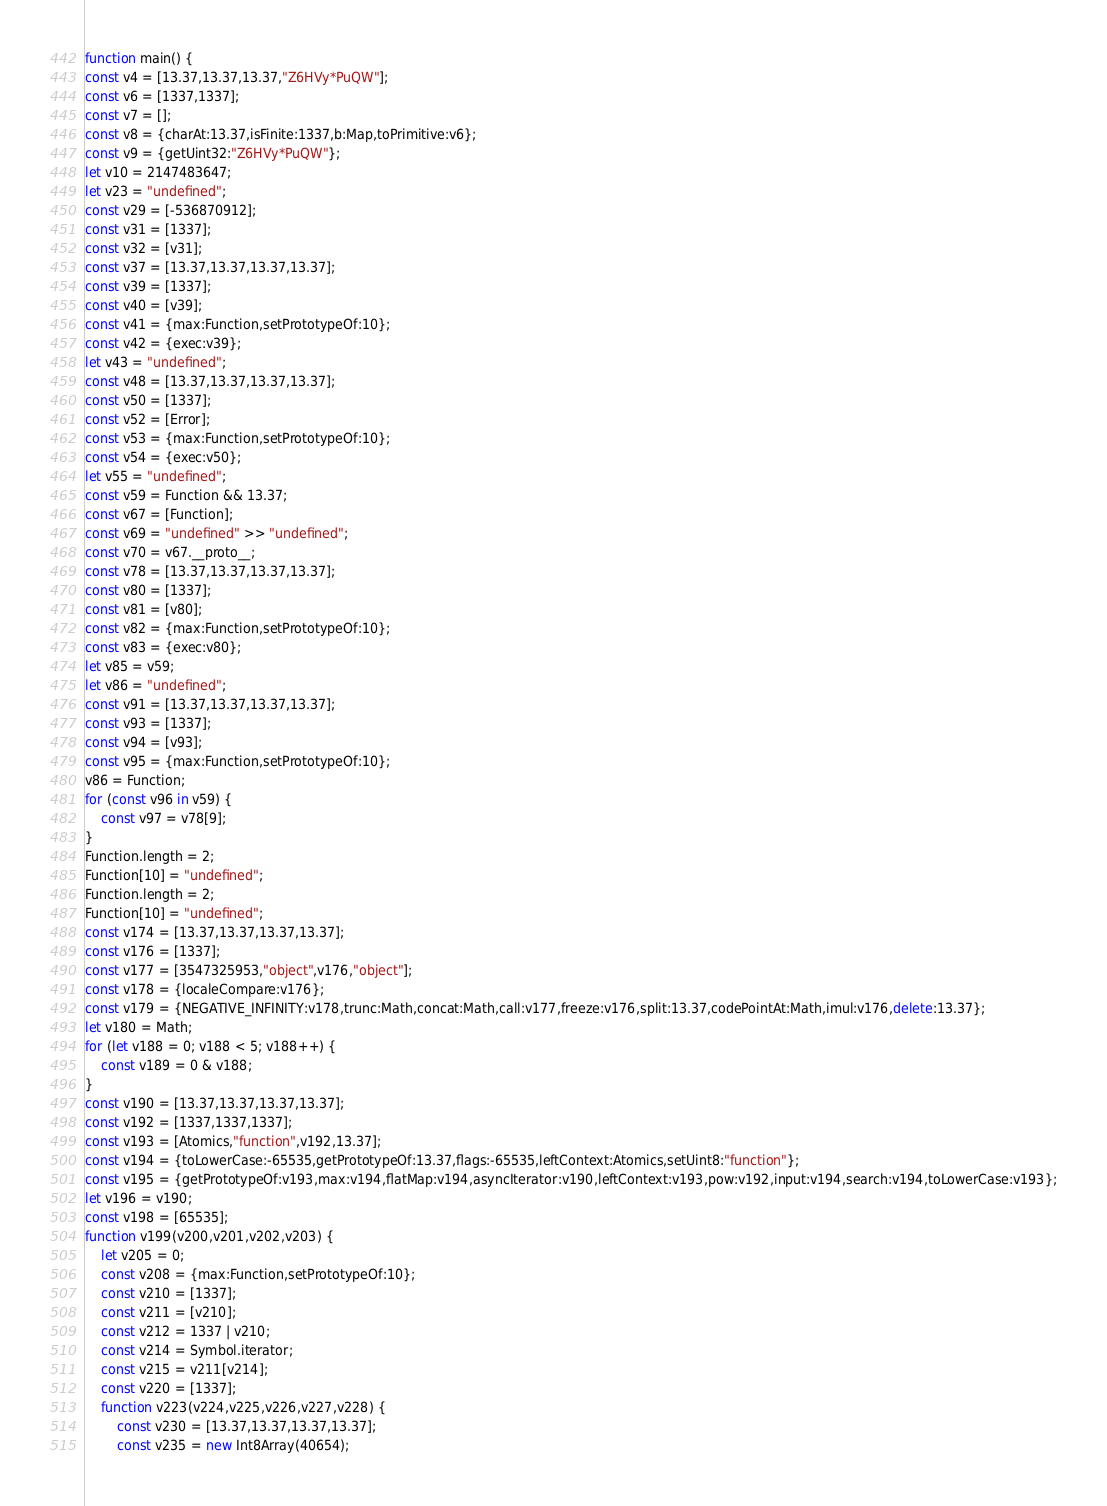Convert code to text. <code><loc_0><loc_0><loc_500><loc_500><_JavaScript_>function main() {
const v4 = [13.37,13.37,13.37,"Z6HVy*PuQW"];
const v6 = [1337,1337];
const v7 = [];
const v8 = {charAt:13.37,isFinite:1337,b:Map,toPrimitive:v6};
const v9 = {getUint32:"Z6HVy*PuQW"};
let v10 = 2147483647;
let v23 = "undefined";
const v29 = [-536870912];
const v31 = [1337];
const v32 = [v31];
const v37 = [13.37,13.37,13.37,13.37];
const v39 = [1337];
const v40 = [v39];
const v41 = {max:Function,setPrototypeOf:10};
const v42 = {exec:v39};
let v43 = "undefined";
const v48 = [13.37,13.37,13.37,13.37];
const v50 = [1337];
const v52 = [Error];
const v53 = {max:Function,setPrototypeOf:10};
const v54 = {exec:v50};
let v55 = "undefined";
const v59 = Function && 13.37;
const v67 = [Function];
const v69 = "undefined" >> "undefined";
const v70 = v67.__proto__;
const v78 = [13.37,13.37,13.37,13.37];
const v80 = [1337];
const v81 = [v80];
const v82 = {max:Function,setPrototypeOf:10};
const v83 = {exec:v80};
let v85 = v59;
let v86 = "undefined";
const v91 = [13.37,13.37,13.37,13.37];
const v93 = [1337];
const v94 = [v93];
const v95 = {max:Function,setPrototypeOf:10};
v86 = Function;
for (const v96 in v59) {
    const v97 = v78[9];
}
Function.length = 2;
Function[10] = "undefined";
Function.length = 2;
Function[10] = "undefined";
const v174 = [13.37,13.37,13.37,13.37];
const v176 = [1337];
const v177 = [3547325953,"object",v176,"object"];
const v178 = {localeCompare:v176};
const v179 = {NEGATIVE_INFINITY:v178,trunc:Math,concat:Math,call:v177,freeze:v176,split:13.37,codePointAt:Math,imul:v176,delete:13.37};
let v180 = Math;
for (let v188 = 0; v188 < 5; v188++) {
    const v189 = 0 & v188;
}
const v190 = [13.37,13.37,13.37,13.37];
const v192 = [1337,1337,1337];
const v193 = [Atomics,"function",v192,13.37];
const v194 = {toLowerCase:-65535,getPrototypeOf:13.37,flags:-65535,leftContext:Atomics,setUint8:"function"};
const v195 = {getPrototypeOf:v193,max:v194,flatMap:v194,asyncIterator:v190,leftContext:v193,pow:v192,input:v194,search:v194,toLowerCase:v193};
let v196 = v190;
const v198 = [65535];
function v199(v200,v201,v202,v203) {
    let v205 = 0;
    const v208 = {max:Function,setPrototypeOf:10};
    const v210 = [1337];
    const v211 = [v210];
    const v212 = 1337 | v210;
    const v214 = Symbol.iterator;
    const v215 = v211[v214];
    const v220 = [1337];
    function v223(v224,v225,v226,v227,v228) {
        const v230 = [13.37,13.37,13.37,13.37];
        const v235 = new Int8Array(40654);</code> 